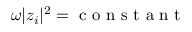Convert formula to latex. <formula><loc_0><loc_0><loc_500><loc_500>\omega | z _ { i } | ^ { 2 } = c o n s t a n t</formula> 